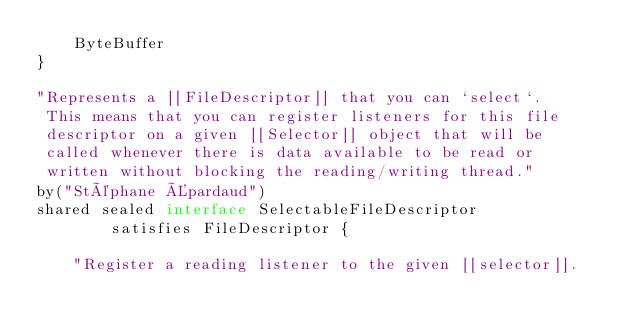<code> <loc_0><loc_0><loc_500><loc_500><_Ceylon_>    ByteBuffer
}

"Represents a [[FileDescriptor]] that you can `select`. 
 This means that you can register listeners for this file 
 descriptor on a given [[Selector]] object that will be 
 called whenever there is data available to be read or 
 written without blocking the reading/writing thread."
by("Stéphane Épardaud")
shared sealed interface SelectableFileDescriptor 
        satisfies FileDescriptor {

    "Register a reading listener to the given [[selector]]. </code> 